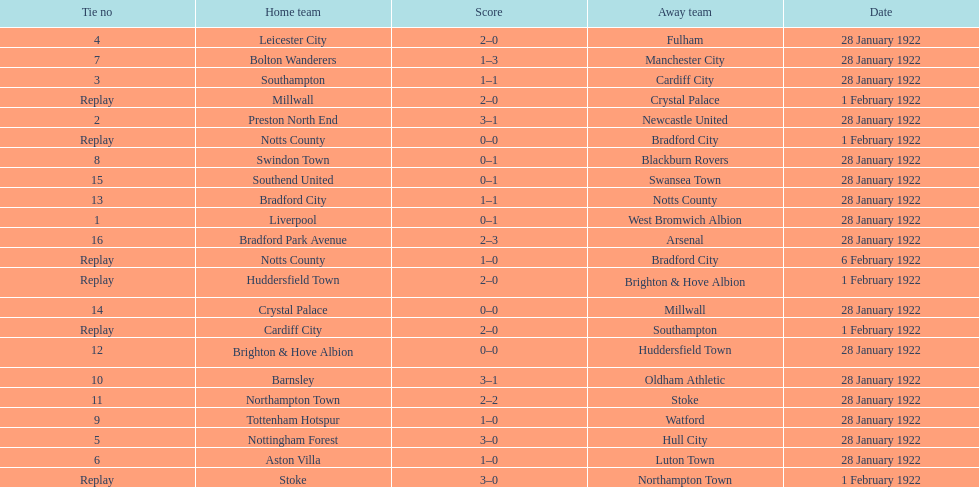Who is the first home team listed as having a score of 3-1? Preston North End. 